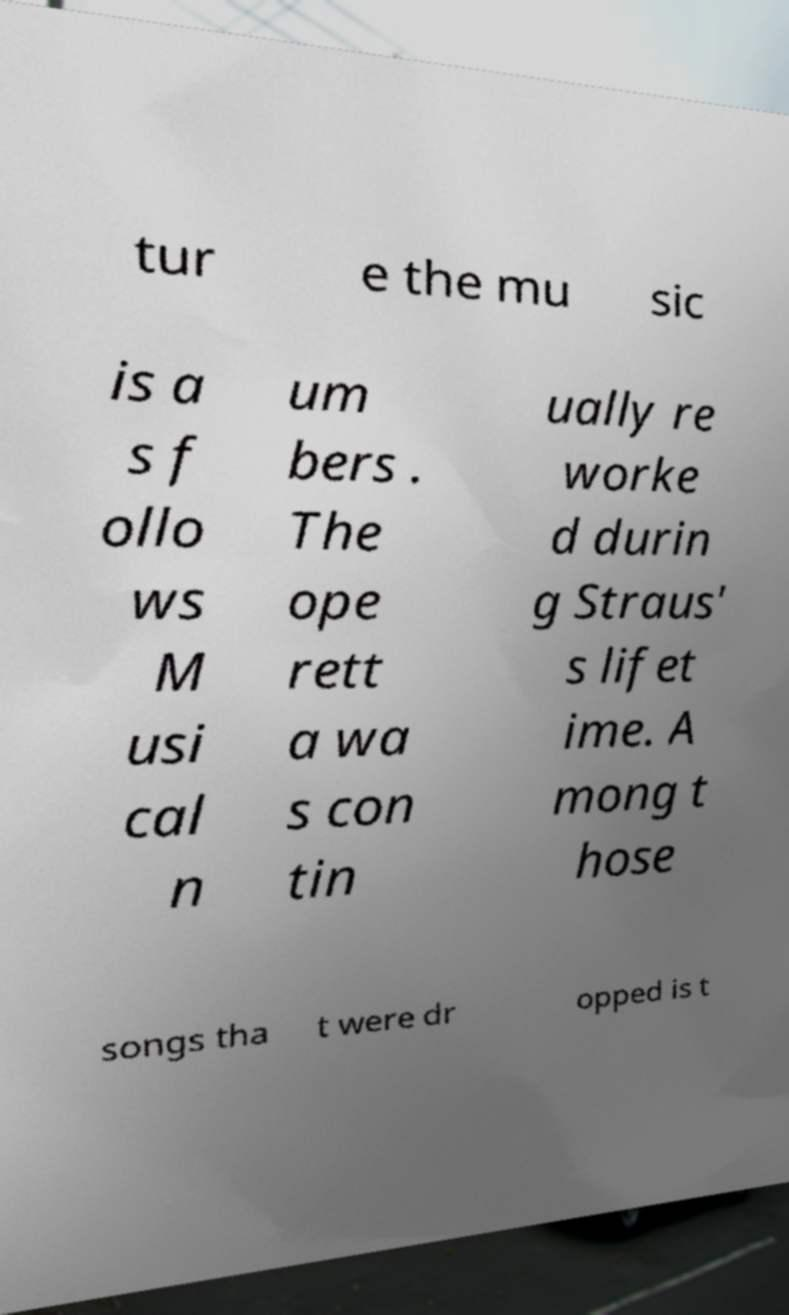Can you read and provide the text displayed in the image?This photo seems to have some interesting text. Can you extract and type it out for me? tur e the mu sic is a s f ollo ws M usi cal n um bers . The ope rett a wa s con tin ually re worke d durin g Straus' s lifet ime. A mong t hose songs tha t were dr opped is t 